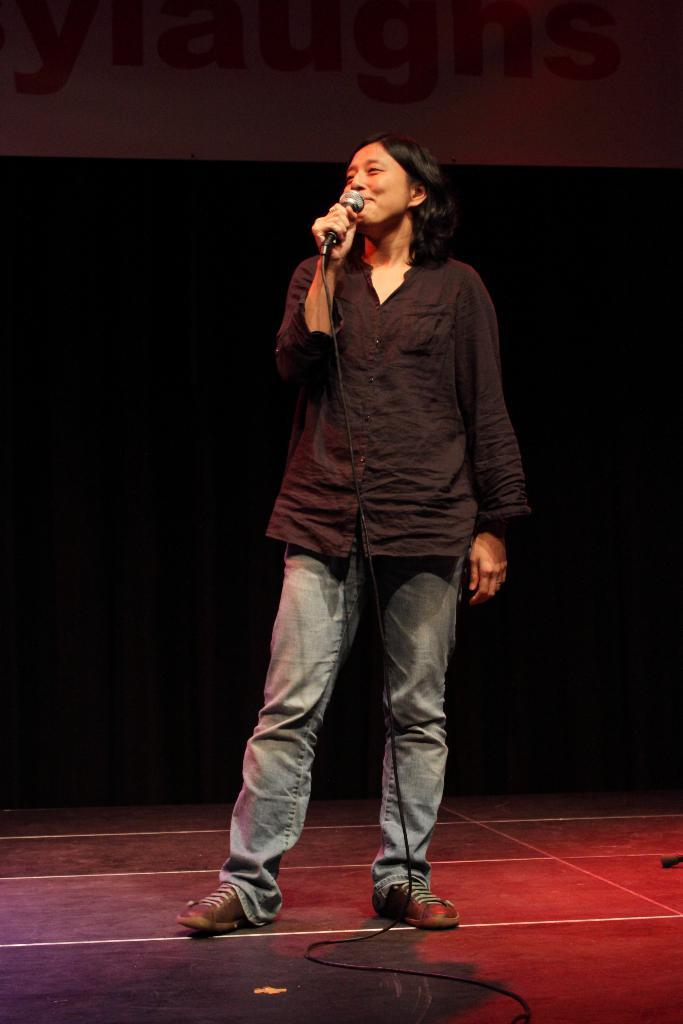What is the main subject of the image? The main subject of the image is a woman. What is the woman doing in the image? The woman is standing and singing a song. What is the woman holding in the image? The woman is holding a microphone. What is the woman wearing in the image? The woman is wearing a black shirt, black trousers, and shoes. Is the woman's sister standing next to her in the image? There is no mention of a sister or another person in the image, so we cannot determine if the woman's sister is present. Can you see a lake in the background of the image? There is no mention of a lake or any body of water in the image, so we cannot determine if there is a lake in the background. 